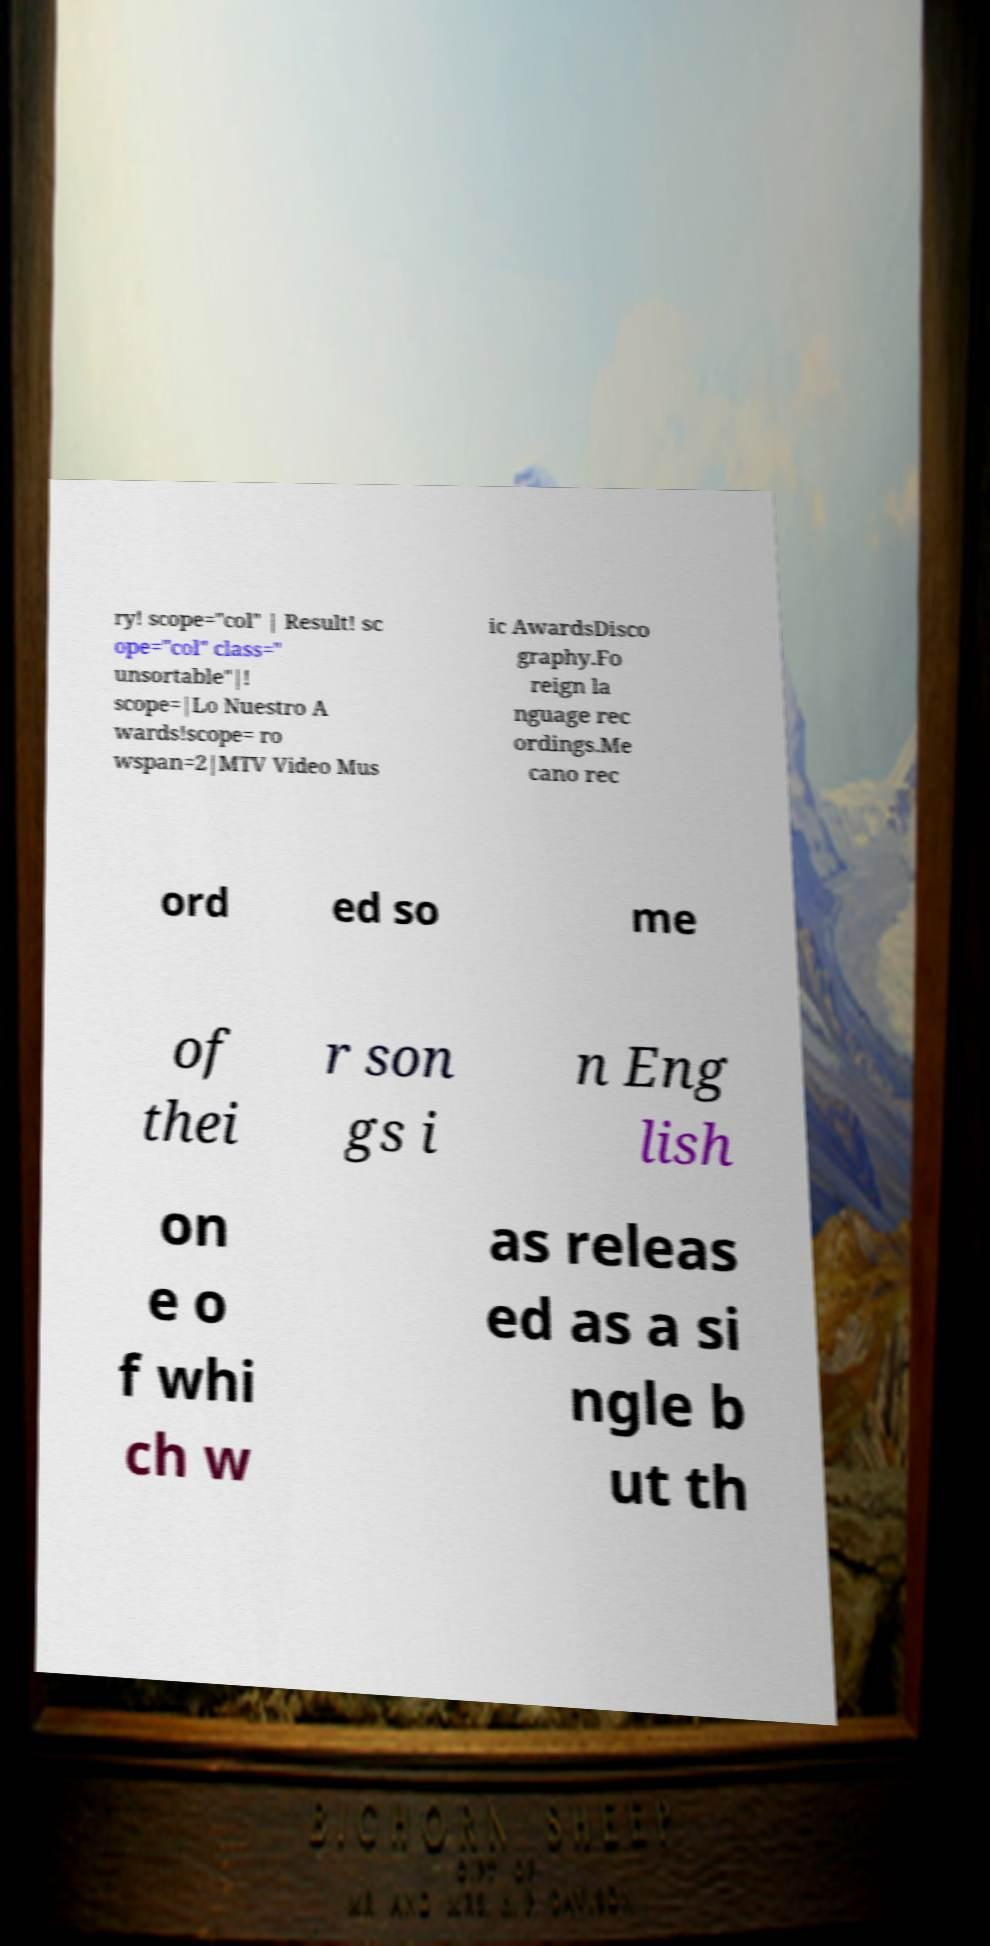Can you read and provide the text displayed in the image?This photo seems to have some interesting text. Can you extract and type it out for me? ry! scope="col" | Result! sc ope="col" class=" unsortable"|! scope=|Lo Nuestro A wards!scope= ro wspan=2|MTV Video Mus ic AwardsDisco graphy.Fo reign la nguage rec ordings.Me cano rec ord ed so me of thei r son gs i n Eng lish on e o f whi ch w as releas ed as a si ngle b ut th 